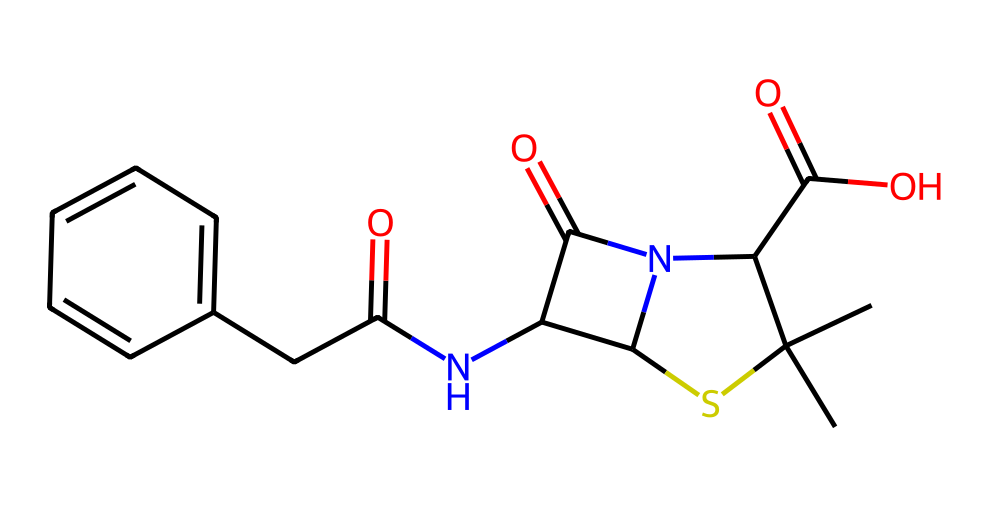What is the molecular formula of penicillin? To find the molecular formula, we can identify the types and counts of each atom in the structure. By examining the structure and the SMILES notation, we see there are carbons (C), nitrogens (N), oxygens (O), and a sulfur (S) present. The total counts are: C = 16, H = 19, N = 2, O = 4, S = 1. Thus, the formula is C16H19N2O4S.
Answer: C16H19N2O4S How many nitrogen atoms are present in the structure? By inspecting the SMILES representation and identifying the nitrogen atoms (N), we can locate them within the structure. There are exactly two N atoms visible.
Answer: 2 What type of functional groups are present in penicillin? Looking at the structure, we can identify specific functional groups. We notice a carboxylic acid group (-COOH) and amine groups (-NH2), which are common in penicillin. Therefore, it includes a carboxylic acid and amide functional groups.
Answer: carboxylic acid and amide What role does sulfur play in the structure of penicillin? The sulfur atom is part of the thiazolidine ring, which is essential for the antibiotic action of penicillin by forming the beta-lactam ring that interferes with bacterial cell wall synthesis. This is a characteristic feature of penicillin's molecular structure.
Answer: antibiotic action Why might penicillin be categorized as an organosulfur compound? Penicillin contains a sulfur atom bonded within its structure, which classifies it as an organosulfur compound. Organosulfur compounds are defined by having sulfur atoms incorporated into carbon-based structures, confirming its categorization.
Answer: contains sulfur What is the significance of the beta-lactam ring in penicillin? The beta-lactam ring is crucial because it enables penicillin to inhibit cell wall synthesis in bacteria, making it an effective antibiotic. This structural aspect is vital for its mechanism of action against bacterial infections.
Answer: inhibits bacterial cell wall synthesis 